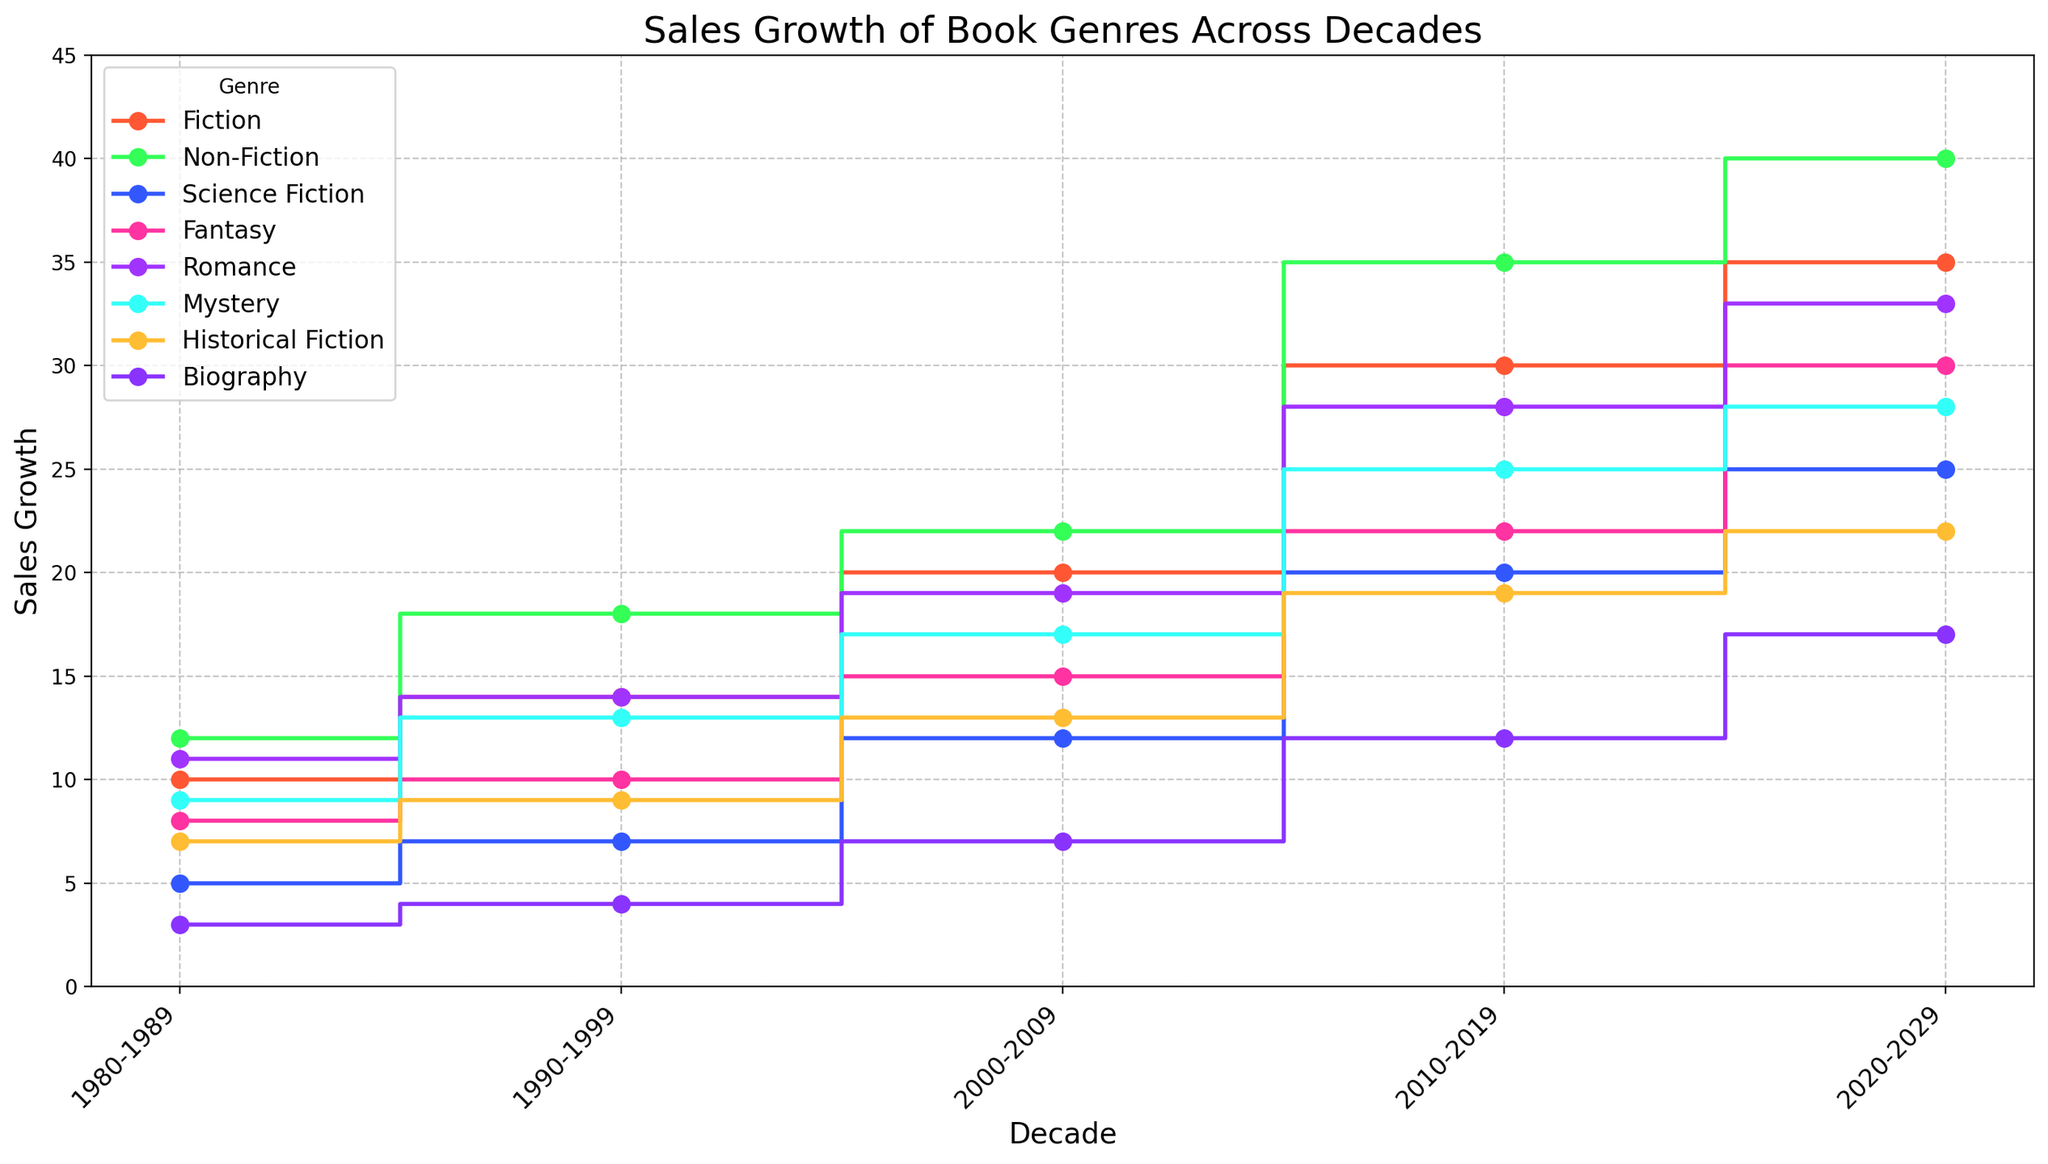What's the sales growth difference between Fiction and Fantasy in 2020-2029? In 2020-2029, Fiction has a sales growth of 35, and Fantasy has a sales growth of 30. The difference is 35 - 30 = 5.
Answer: 5 Which genre experienced the highest growth between 1980-1989 and 2020-2029? Comparing increases, Fiction grows from 10 to 35 (25 units), Non-Fiction from 12 to 40 (28 units), Science Fiction from 5 to 25 (20 units), Fantasy from 8 to 30 (22 units), Romance from 11 to 33 (22 units), Mystery from 9 to 28 (19 units), Historical Fiction from 7 to 22 (15 units), and Biography from 3 to 17 (14 units). Non-Fiction has the highest increase of 28 units.
Answer: Non-Fiction In which decade did Mystery surpass Romance in sales growth for the first time? By comparing the decades: 1980-1989 (Romance: 11, Mystery: 9), 1990-1999 (Romance: 14, Mystery: 13), 2000-2009 (Romance: 19, Mystery: 17), 2010-2019 (Romance: 28, Mystery: 25), and 2020-2029 (Romance: 33, Mystery: 28), Romance always has higher sales growth than Mystery in each decade, so Mystery never surpasses Romance.
Answer: Never What's the combined sales growth for all genres in the 2010-2019 decade? Adding the sales growths of all genres in 2010-2019: 30 (Fiction) + 35 (Non-Fiction) + 20 (Science Fiction) + 22 (Fantasy) + 28 (Romance) + 25 (Mystery) + 19 (Historical Fiction) + 12 (Biography) = 191.
Answer: 191 Which genres have equal sales growth in 2010-2019 and how much is it? In 2010-2019, looking at the chart, the bars for Mystery (25) and Biography (12) are distinct from each other and don't overlap in value with any other genre; therefore, none of the genres has equal sales growth.
Answer: None Is the growth trend of Science Fiction consistently increasing over all decades? Observing Science Fiction data: 1980-1989 (5), 1990-1999 (7), 2000-2009 (12), 2010-2019 (20), 2020-2029 (25), each decade shows an increment from the previous one, indicating a consistent increasing trend.
Answer: Yes How does the sales growth of Biography in 2020-2029 compare to that of Historical Fiction in the same decade? The sales growth of Biography in 2020-2029 is 17, while for Historical Fiction it is 22. Comparing the two numbers, 17 is less than 22.
Answer: Less What is the average sales growth of Romance genre over the last three decades? For Romance in 2000-2009 (19), 2010-2019 (28), and 2020-2029 (33), the average is (19 + 28 + 33) / 3 = 26.67.
Answer: 26.67 Which genre had the smallest increase in sales growth from 2000-2009 to 2010-2019? Differences by genre: Fiction (10 units), Non-Fiction (13), Science Fiction (8), Fantasy (7), Romance (9), Mystery (8), Historical Fiction (6), and Biography (5). Biography has the smallest increase.
Answer: Biography 